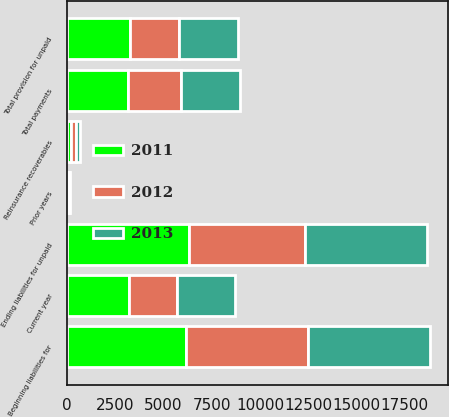Convert chart to OTSL. <chart><loc_0><loc_0><loc_500><loc_500><stacked_bar_chart><ecel><fcel>Beginning liabilities for<fcel>Reinsurance recoverables<fcel>Current year<fcel>Prior years<fcel>Total provision for unpaid<fcel>Total payments<fcel>Ending liabilities for unpaid<nl><fcel>2012<fcel>6295<fcel>252<fcel>2534<fcel>17<fcel>2517<fcel>2771<fcel>6041<nl><fcel>2013<fcel>6314<fcel>233<fcel>2989<fcel>52<fcel>3041<fcel>3060<fcel>6295<nl><fcel>2011<fcel>6179<fcel>209<fcel>3196<fcel>98<fcel>3294<fcel>3159<fcel>6314<nl></chart> 